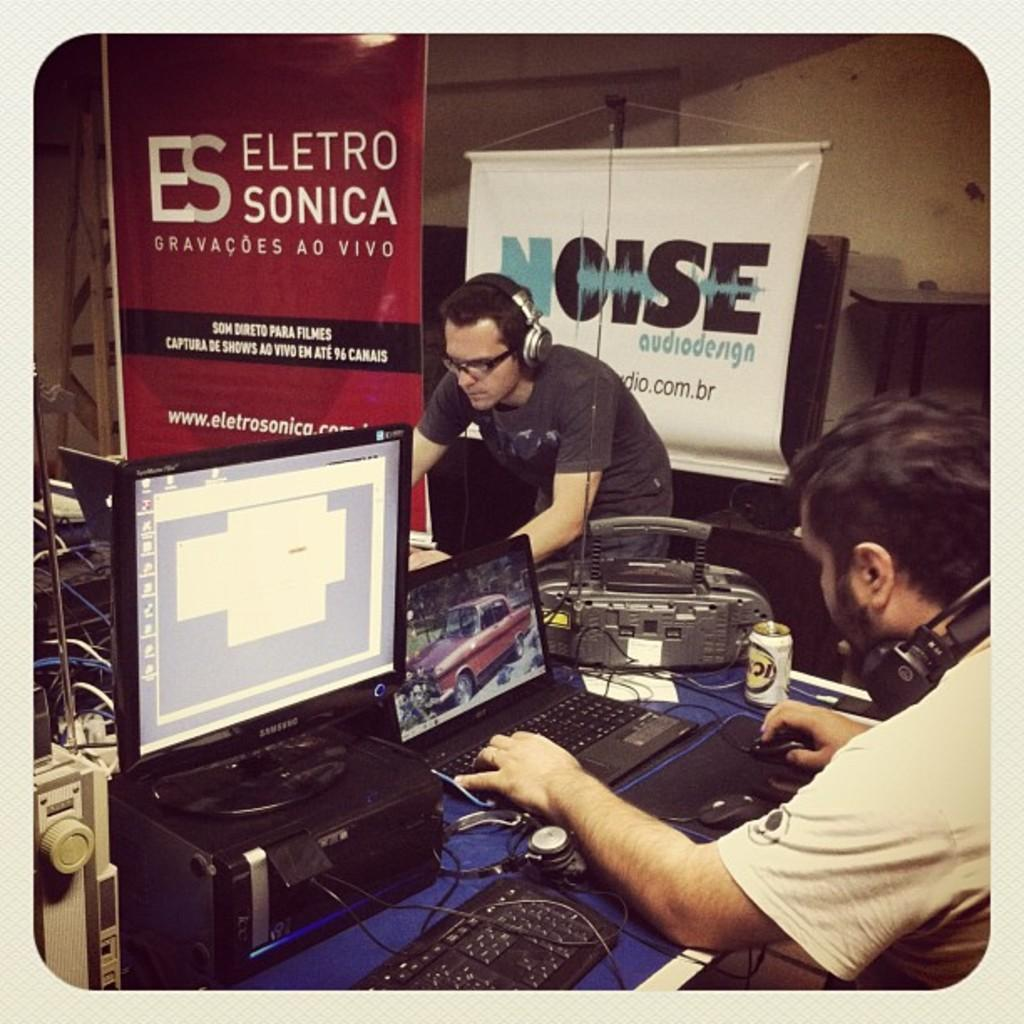<image>
Relay a brief, clear account of the picture shown. A man with headphones is standing in front of a banner that says "Noise audio design" 